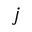Convert formula to latex. <formula><loc_0><loc_0><loc_500><loc_500>j</formula> 